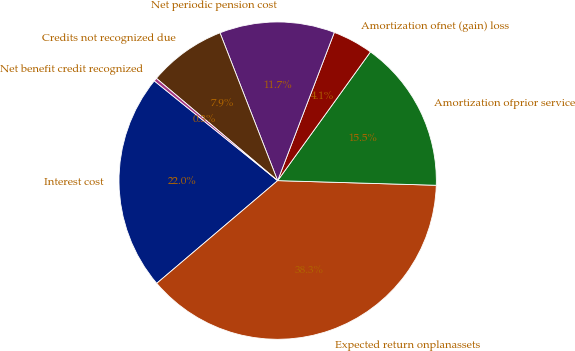<chart> <loc_0><loc_0><loc_500><loc_500><pie_chart><fcel>Interest cost<fcel>Expected return onplanassets<fcel>Amortization ofprior service<fcel>Amortization ofnet (gain) loss<fcel>Net periodic pension cost<fcel>Credits not recognized due<fcel>Net benefit credit recognized<nl><fcel>22.03%<fcel>38.33%<fcel>15.53%<fcel>4.13%<fcel>11.73%<fcel>7.93%<fcel>0.33%<nl></chart> 